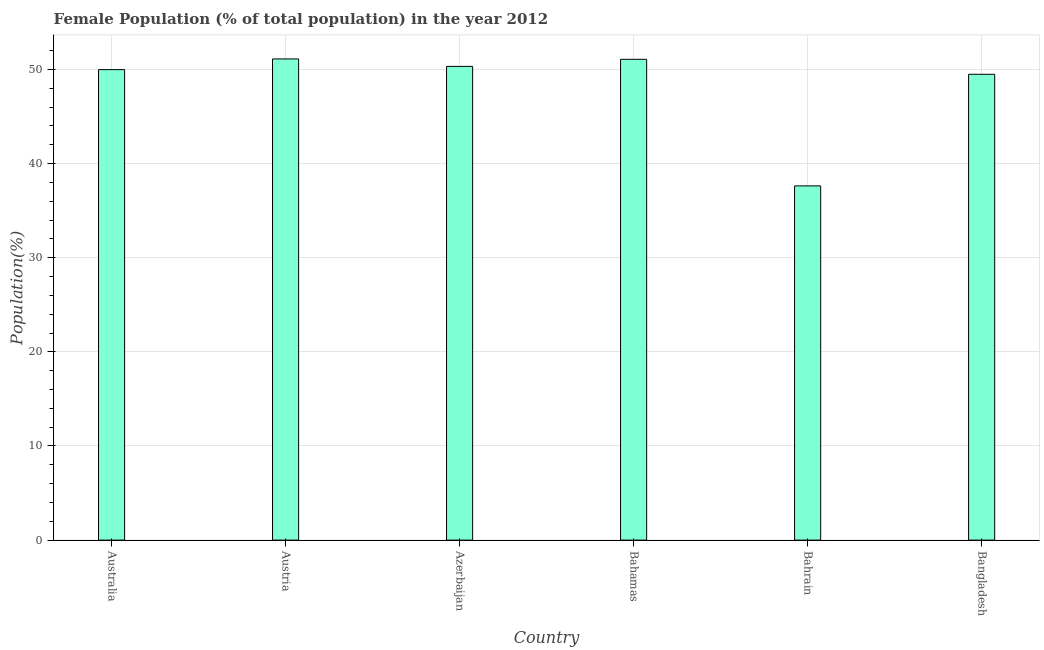What is the title of the graph?
Your answer should be compact. Female Population (% of total population) in the year 2012. What is the label or title of the X-axis?
Provide a succinct answer. Country. What is the label or title of the Y-axis?
Offer a very short reply. Population(%). What is the female population in Azerbaijan?
Make the answer very short. 50.33. Across all countries, what is the maximum female population?
Your response must be concise. 51.12. Across all countries, what is the minimum female population?
Provide a succinct answer. 37.63. In which country was the female population minimum?
Keep it short and to the point. Bahrain. What is the sum of the female population?
Offer a terse response. 289.66. What is the difference between the female population in Australia and Austria?
Offer a terse response. -1.14. What is the average female population per country?
Offer a very short reply. 48.28. What is the median female population?
Offer a very short reply. 50.16. In how many countries, is the female population greater than 34 %?
Offer a terse response. 6. What is the difference between the highest and the second highest female population?
Provide a succinct answer. 0.04. Is the sum of the female population in Australia and Bahrain greater than the maximum female population across all countries?
Ensure brevity in your answer.  Yes. What is the difference between the highest and the lowest female population?
Give a very brief answer. 13.49. In how many countries, is the female population greater than the average female population taken over all countries?
Offer a very short reply. 5. How many bars are there?
Offer a terse response. 6. How many countries are there in the graph?
Your response must be concise. 6. Are the values on the major ticks of Y-axis written in scientific E-notation?
Your answer should be very brief. No. What is the Population(%) in Australia?
Your answer should be compact. 49.99. What is the Population(%) of Austria?
Offer a terse response. 51.12. What is the Population(%) of Azerbaijan?
Your answer should be compact. 50.33. What is the Population(%) in Bahamas?
Offer a very short reply. 51.09. What is the Population(%) in Bahrain?
Make the answer very short. 37.63. What is the Population(%) of Bangladesh?
Keep it short and to the point. 49.49. What is the difference between the Population(%) in Australia and Austria?
Make the answer very short. -1.14. What is the difference between the Population(%) in Australia and Azerbaijan?
Offer a very short reply. -0.34. What is the difference between the Population(%) in Australia and Bahamas?
Keep it short and to the point. -1.1. What is the difference between the Population(%) in Australia and Bahrain?
Your response must be concise. 12.36. What is the difference between the Population(%) in Australia and Bangladesh?
Offer a very short reply. 0.5. What is the difference between the Population(%) in Austria and Azerbaijan?
Give a very brief answer. 0.79. What is the difference between the Population(%) in Austria and Bahamas?
Offer a terse response. 0.04. What is the difference between the Population(%) in Austria and Bahrain?
Make the answer very short. 13.49. What is the difference between the Population(%) in Austria and Bangladesh?
Give a very brief answer. 1.63. What is the difference between the Population(%) in Azerbaijan and Bahamas?
Your answer should be very brief. -0.75. What is the difference between the Population(%) in Azerbaijan and Bahrain?
Provide a succinct answer. 12.7. What is the difference between the Population(%) in Azerbaijan and Bangladesh?
Make the answer very short. 0.84. What is the difference between the Population(%) in Bahamas and Bahrain?
Offer a very short reply. 13.45. What is the difference between the Population(%) in Bahamas and Bangladesh?
Ensure brevity in your answer.  1.59. What is the difference between the Population(%) in Bahrain and Bangladesh?
Keep it short and to the point. -11.86. What is the ratio of the Population(%) in Australia to that in Austria?
Provide a short and direct response. 0.98. What is the ratio of the Population(%) in Australia to that in Azerbaijan?
Your answer should be compact. 0.99. What is the ratio of the Population(%) in Australia to that in Bahrain?
Your response must be concise. 1.33. What is the ratio of the Population(%) in Australia to that in Bangladesh?
Give a very brief answer. 1.01. What is the ratio of the Population(%) in Austria to that in Azerbaijan?
Provide a short and direct response. 1.02. What is the ratio of the Population(%) in Austria to that in Bahrain?
Provide a succinct answer. 1.36. What is the ratio of the Population(%) in Austria to that in Bangladesh?
Give a very brief answer. 1.03. What is the ratio of the Population(%) in Azerbaijan to that in Bahamas?
Provide a succinct answer. 0.98. What is the ratio of the Population(%) in Azerbaijan to that in Bahrain?
Your response must be concise. 1.34. What is the ratio of the Population(%) in Azerbaijan to that in Bangladesh?
Provide a succinct answer. 1.02. What is the ratio of the Population(%) in Bahamas to that in Bahrain?
Provide a succinct answer. 1.36. What is the ratio of the Population(%) in Bahamas to that in Bangladesh?
Offer a terse response. 1.03. What is the ratio of the Population(%) in Bahrain to that in Bangladesh?
Give a very brief answer. 0.76. 